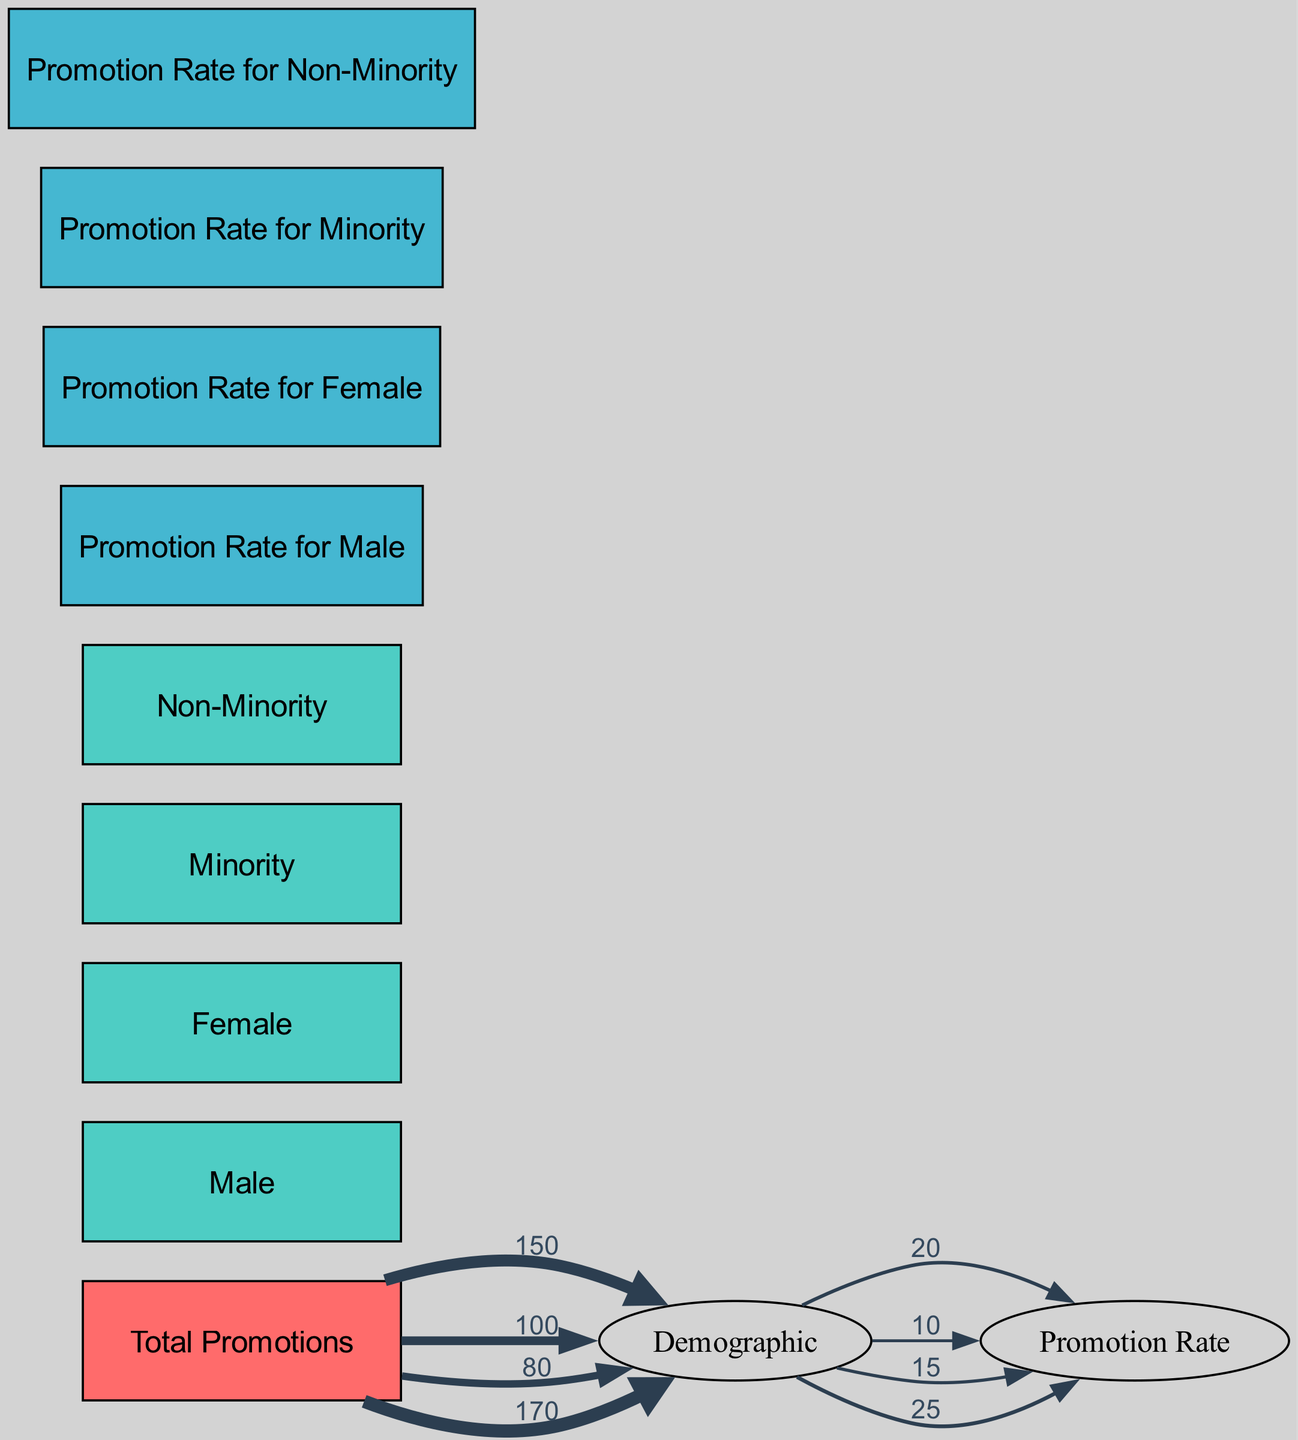What is the total number of promotions for males? The diagram indicates that the total promotions for males is represented by a direct link from "Total Promotions" to "Demographic: Male." The value displayed on this link shows that there are 150 promotions for males.
Answer: 150 What is the total number of promotions for females? The total number of promotions for females is indicated by the link from "Total Promotions" to "Demographic: Female." The value shown on this link is 100.
Answer: 100 How many promotions were given to minorities? To find the promotions given to minorities, we look for the link from "Total Promotions" to "Demographic: Minority," which shows a value of 80.
Answer: 80 What is the promotion rate for non-minorities? The promotion rate for non-minorities can be found by examining the link from "Demographic: Non-Minority" to "Promotion Rate: Non-Minority." The value on this link shows that the promotion rate for non-minorities is 25.
Answer: 25 Which demographic received the most promotions? By comparing the values from the "Total Promotions" to each demographic, we find that "Demographic: Non-Minority" has the largest value at 170, indicating that they received the most promotions.
Answer: Non-Minority What is the total number of promotions across all demographics? The total number of promotions across all demographics can be understood as the sum of the values from the "Total Promotions" node to each demographic node. Adding the values 150 (Male) + 100 (Female) + 80 (Minority) + 170 (Non-Minority) gives us a total of 500 promotions.
Answer: 500 Which demographic has the highest promotion rate? To determine the highest promotion rate, we need to examine the values of the promotion rates for each demographic: 20 (Male), 10 (Female), 15 (Minority), and 25 (Non-Minority). The highest value is 25, indicating that non-minorities have the highest promotion rate.
Answer: Non-Minority What is the total number of links in the diagram? The total number of links is counted in the diagram. There are 8 links that connect various nodes, representing the flow of promotions and rates.
Answer: 8 What is the relationship between total promotions and minorities? The relationship is illustrated by a direct link from "Total Promotions" to "Demographic: Minority" which shows that minorities received a total of 80 promotions.
Answer: 80 Promotions What is the lowest promotion rate among the demographics? To find the lowest promotion rate, we check the values: 20 (Male), 10 (Female), 15 (Minority), and 25 (Non-Minority). The lowest rate is 10, associated with females.
Answer: 10 